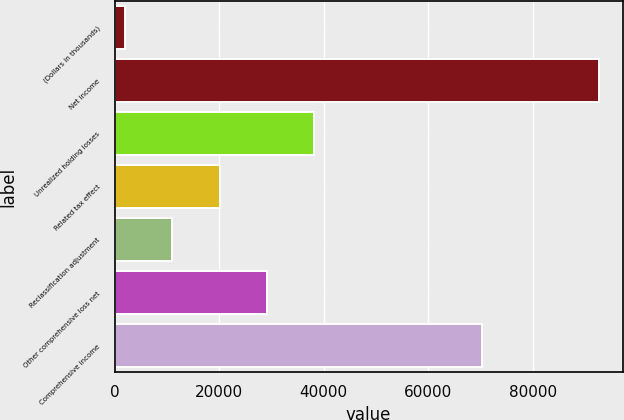<chart> <loc_0><loc_0><loc_500><loc_500><bar_chart><fcel>(Dollars in thousands)<fcel>Net income<fcel>Unrealized holding losses<fcel>Related tax effect<fcel>Reclassification adjustment<fcel>Other comprehensive loss net<fcel>Comprehensive income<nl><fcel>2005<fcel>92537<fcel>38217.8<fcel>20111.4<fcel>11058.2<fcel>29164.6<fcel>70156<nl></chart> 